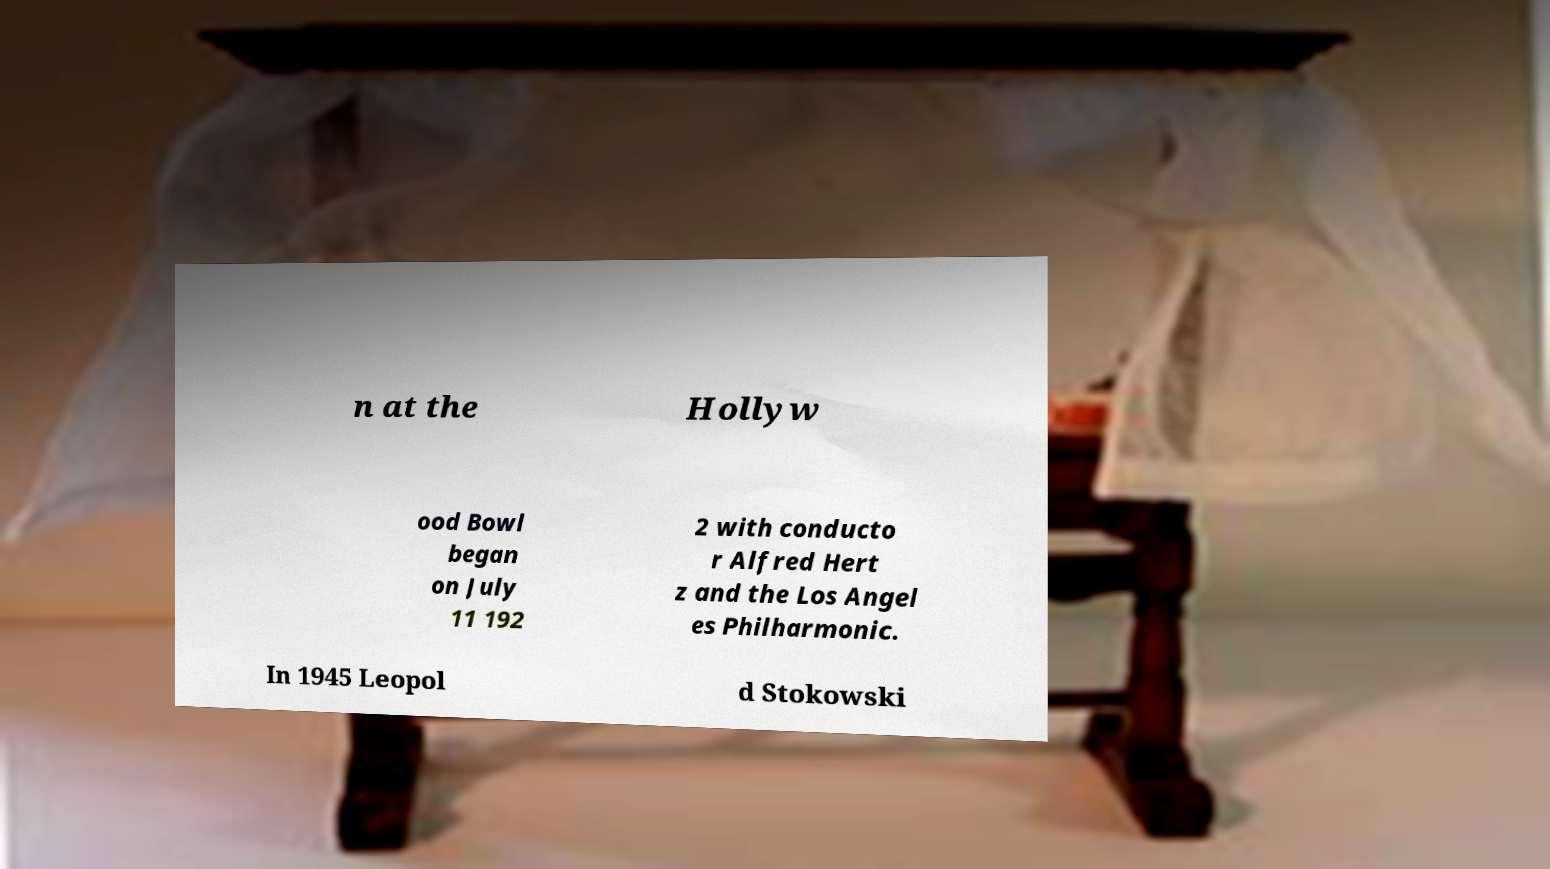Please identify and transcribe the text found in this image. n at the Hollyw ood Bowl began on July 11 192 2 with conducto r Alfred Hert z and the Los Angel es Philharmonic. In 1945 Leopol d Stokowski 